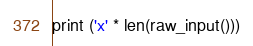Convert code to text. <code><loc_0><loc_0><loc_500><loc_500><_Python_>print ('x' * len(raw_input()))</code> 